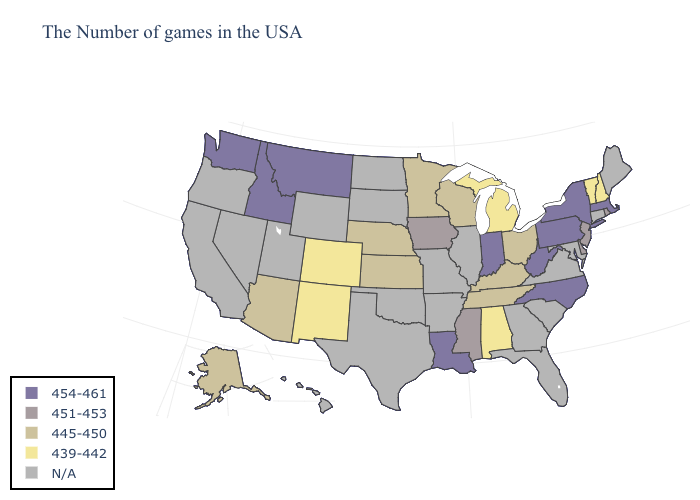Does the first symbol in the legend represent the smallest category?
Answer briefly. No. What is the value of Washington?
Be succinct. 454-461. Name the states that have a value in the range 454-461?
Give a very brief answer. Massachusetts, New York, Pennsylvania, North Carolina, West Virginia, Indiana, Louisiana, Montana, Idaho, Washington. Name the states that have a value in the range 454-461?
Concise answer only. Massachusetts, New York, Pennsylvania, North Carolina, West Virginia, Indiana, Louisiana, Montana, Idaho, Washington. Which states hav the highest value in the MidWest?
Answer briefly. Indiana. Name the states that have a value in the range 445-450?
Short answer required. Ohio, Kentucky, Tennessee, Wisconsin, Minnesota, Kansas, Nebraska, Arizona, Alaska. Name the states that have a value in the range 451-453?
Concise answer only. Rhode Island, New Jersey, Delaware, Mississippi, Iowa. What is the highest value in the Northeast ?
Keep it brief. 454-461. Does Michigan have the highest value in the MidWest?
Concise answer only. No. Among the states that border New Hampshire , which have the highest value?
Keep it brief. Massachusetts. What is the lowest value in the USA?
Keep it brief. 439-442. What is the value of Wisconsin?
Short answer required. 445-450. 